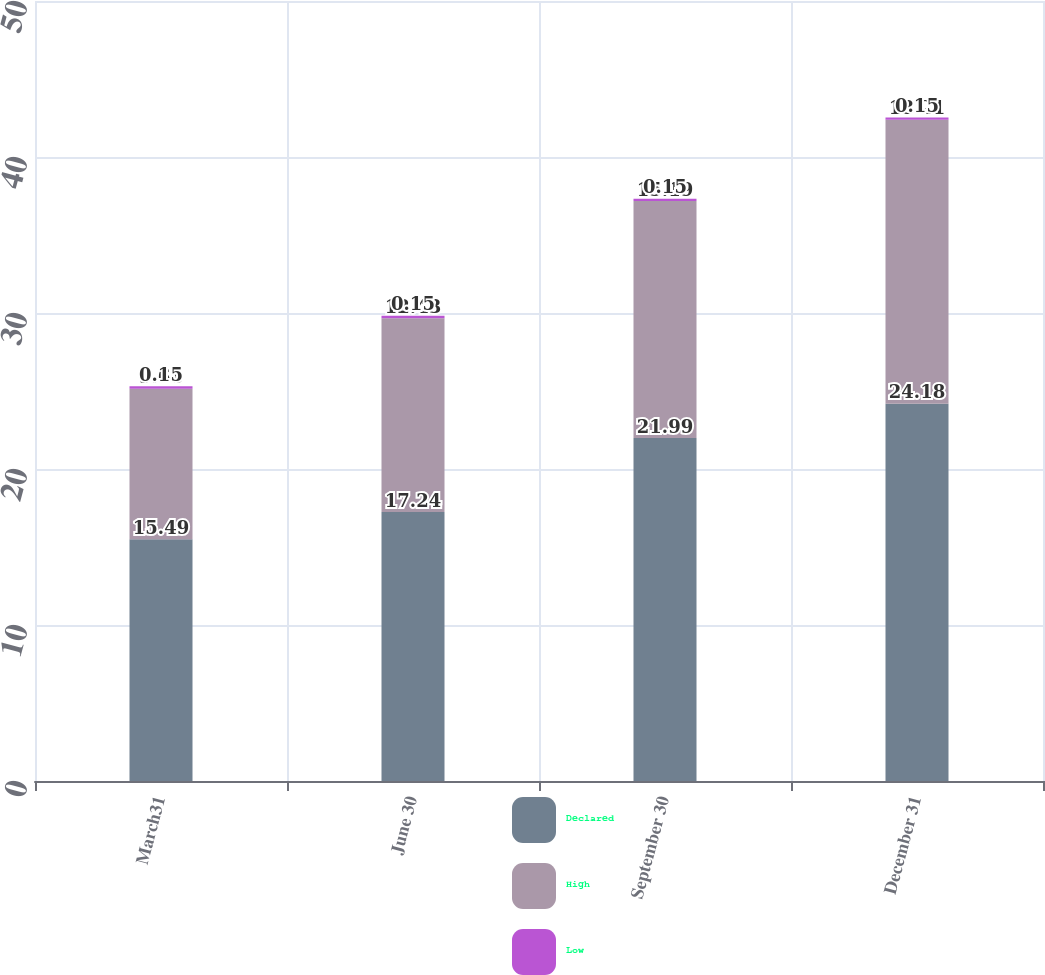Convert chart to OTSL. <chart><loc_0><loc_0><loc_500><loc_500><stacked_bar_chart><ecel><fcel>March31<fcel>June 30<fcel>September 30<fcel>December 31<nl><fcel>Declared<fcel>15.49<fcel>17.24<fcel>21.99<fcel>24.18<nl><fcel>High<fcel>9.66<fcel>12.43<fcel>15.19<fcel>18.21<nl><fcel>Low<fcel>0.15<fcel>0.15<fcel>0.15<fcel>0.15<nl></chart> 